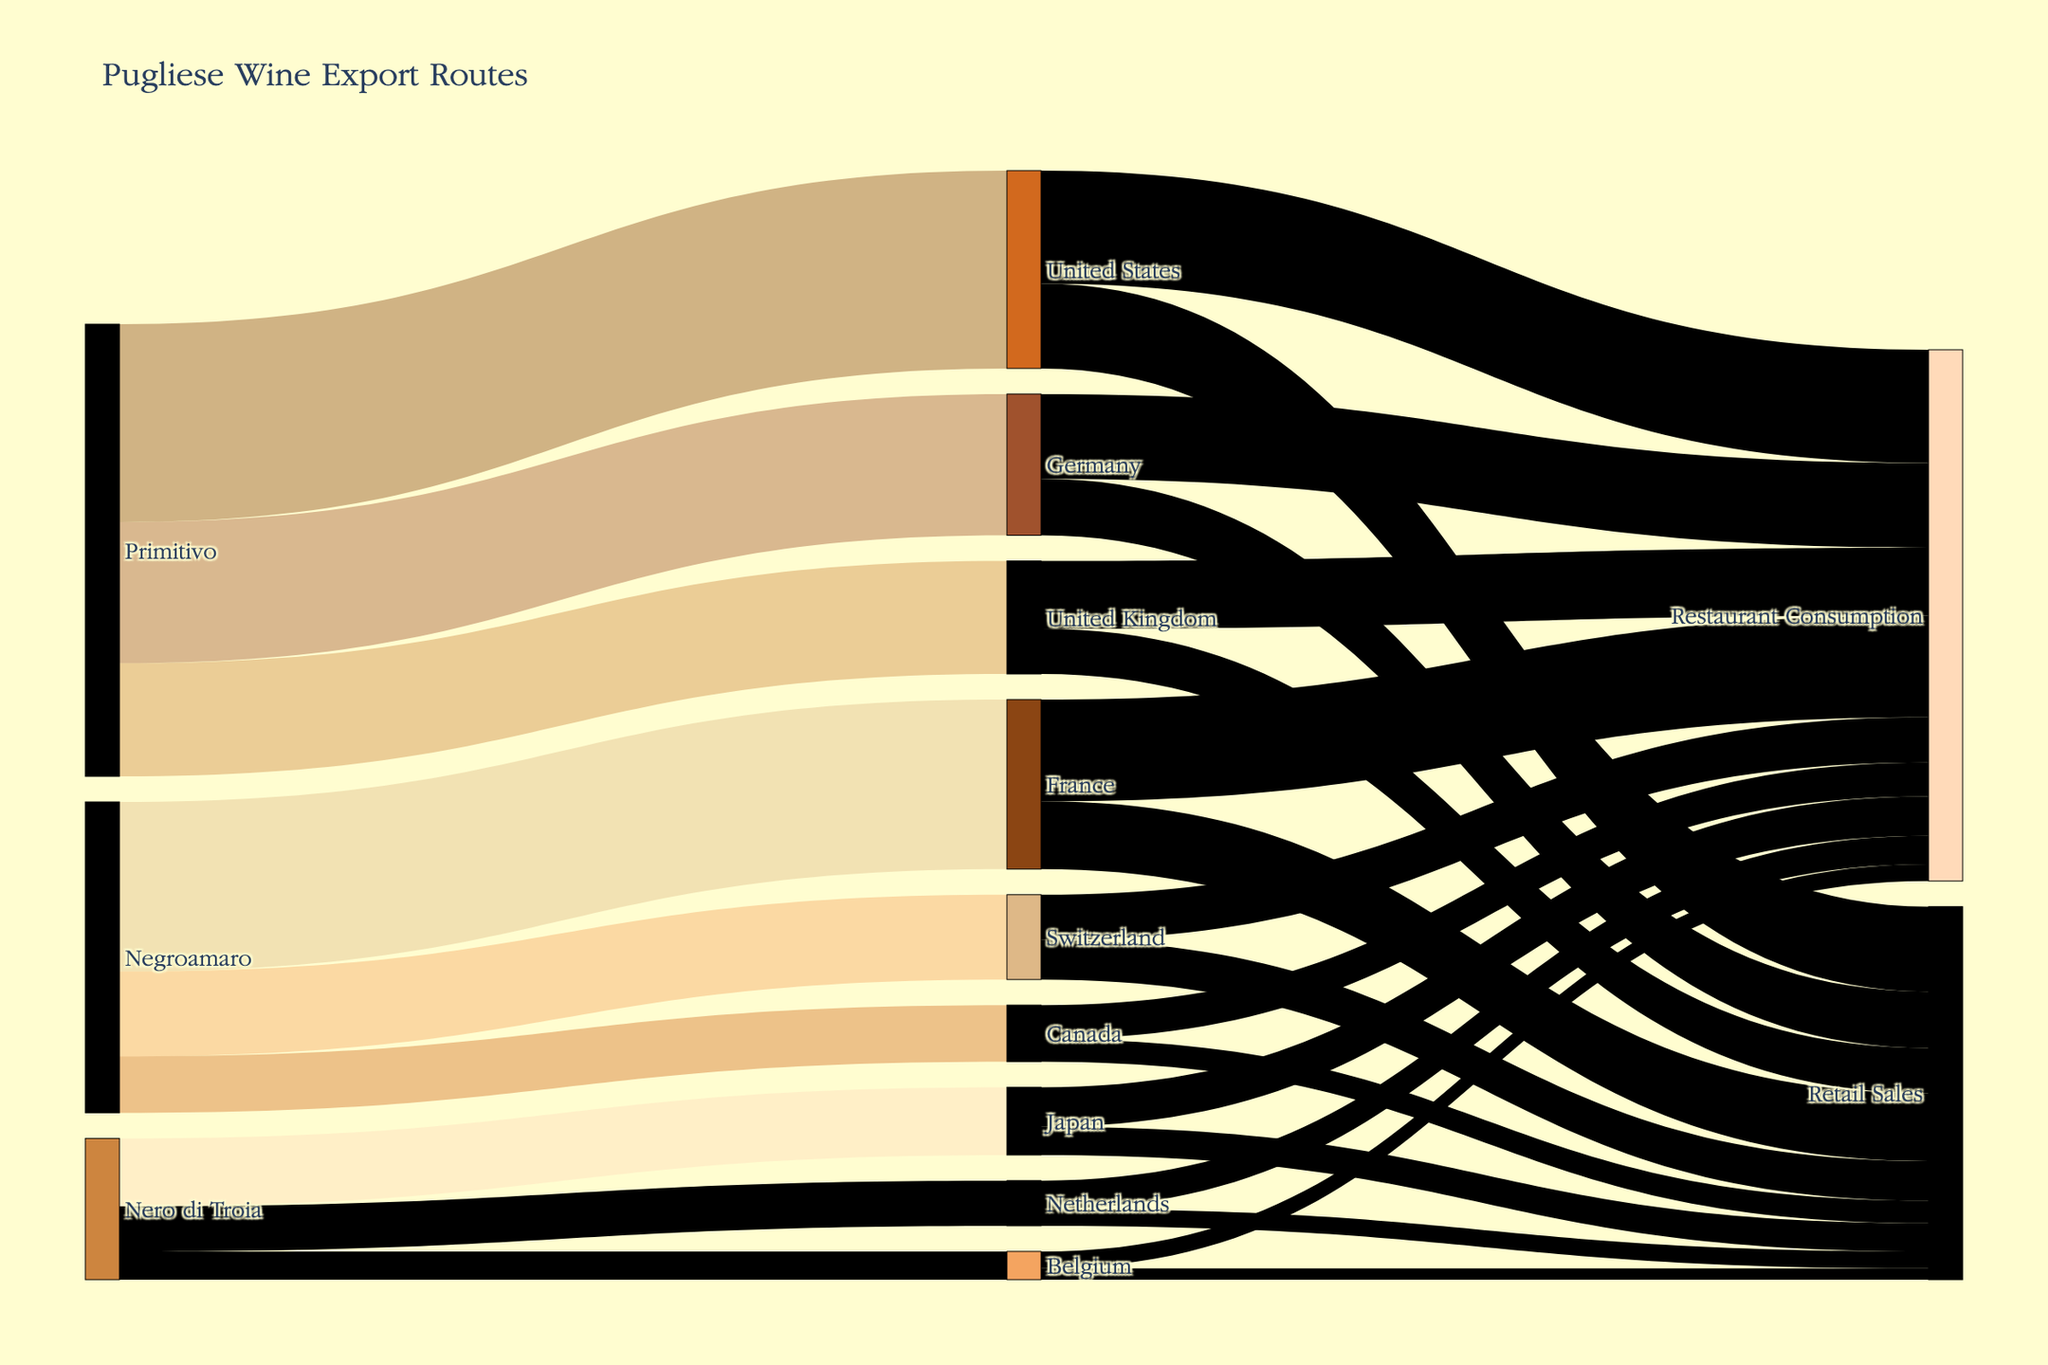What is the title of the figure? The title is displayed at the top of the Sankey Diagram, which sets the context for the visualized data.
Answer: Pugliese Wine Export Routes Which grape variety has the highest total export value? To find this, look at the nodes representing grape varieties and sum the outgoing values for each variety. Primitivo has values of 35, 25, and 20, totaling 80. Negroamaro has 30, 15, and 10, totaling 55. Nero di Troia has 12, 8, and 5, totaling 25. Thus, Primitivo has the highest total.
Answer: Primitivo What is the total exported value to the United States? Find the edges leading to the United States and sum their values. Primitivo to United States equates to 35.
Answer: 35 Which country has the highest restaurant consumption of Pugliese wines? Look at the nodes labeled "Restaurant Consumption" under each country, then compare their values. The United States has 20, Germany has 15, the United Kingdom has 12, France has 18, Switzerland has 8, Canada has 6, Japan has 7, the Netherlands has 5, and Belgium has 3. The United States has the highest value.
Answer: United States How much Primitivo wine is exported compared to Negroamaro wine? Compare the total outgoing values for Primitivo (35 + 25 + 20) and Negroamaro (30 + 15 + 10). Primitivo totals 80 and Negroamaro totals 55.
Answer: 25 more for Primitivo What percentage of total Pugliese wine exports goes to restaurants in the United States? First, find the total exports to the United States, which is 35, then find the amount used in restaurants, which is 20. The percentage is (20 / 35) * 100 = 57.14%.
Answer: 57.14% Which grape variety is exported to the fewest number of countries? Count the outgoing connections from each grape variety node. Primitivo has 3, Negroamaro has 3, and Nero di Troia has 3. None is exported to fewer countries; all have equal counts.
Answer: All have equal counts How does retail sales in Germany compare to retail sales in the United Kingdom? Look at the "Retail Sales" nodes under Germany and the United Kingdom. Germany has 10 and the United Kingdom has 8, so Germany’s retail sales are higher.
Answer: Germany's are higher Which destinations receive less than 10% of their wine allocation for retail sales, and how much is it? Calculate 10% of each country’s total (imports), then compare it with the retail sales values. For small values like Belgium, the total from the three types of wine is 5, 10% is 0.5, retail sales are 2 (which is more than 0.5). For Germany, the total is 25 + 15 = 40; 10% of 40 is 4, and its retail sales is 10. For others, their retail sales are always less than 10%.
Answer: None 